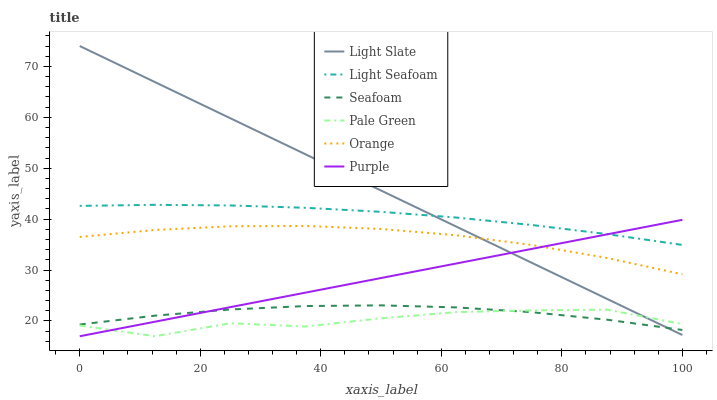Does Pale Green have the minimum area under the curve?
Answer yes or no. Yes. Does Light Slate have the maximum area under the curve?
Answer yes or no. Yes. Does Seafoam have the minimum area under the curve?
Answer yes or no. No. Does Seafoam have the maximum area under the curve?
Answer yes or no. No. Is Purple the smoothest?
Answer yes or no. Yes. Is Pale Green the roughest?
Answer yes or no. Yes. Is Seafoam the smoothest?
Answer yes or no. No. Is Seafoam the roughest?
Answer yes or no. No. Does Purple have the lowest value?
Answer yes or no. Yes. Does Seafoam have the lowest value?
Answer yes or no. No. Does Light Slate have the highest value?
Answer yes or no. Yes. Does Seafoam have the highest value?
Answer yes or no. No. Is Seafoam less than Light Seafoam?
Answer yes or no. Yes. Is Light Seafoam greater than Orange?
Answer yes or no. Yes. Does Orange intersect Light Slate?
Answer yes or no. Yes. Is Orange less than Light Slate?
Answer yes or no. No. Is Orange greater than Light Slate?
Answer yes or no. No. Does Seafoam intersect Light Seafoam?
Answer yes or no. No. 